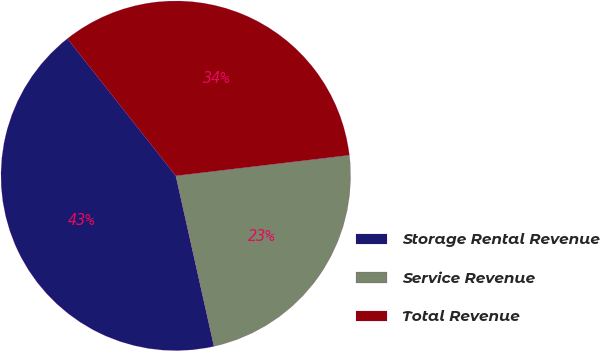<chart> <loc_0><loc_0><loc_500><loc_500><pie_chart><fcel>Storage Rental Revenue<fcel>Service Revenue<fcel>Total Revenue<nl><fcel>42.86%<fcel>23.38%<fcel>33.77%<nl></chart> 